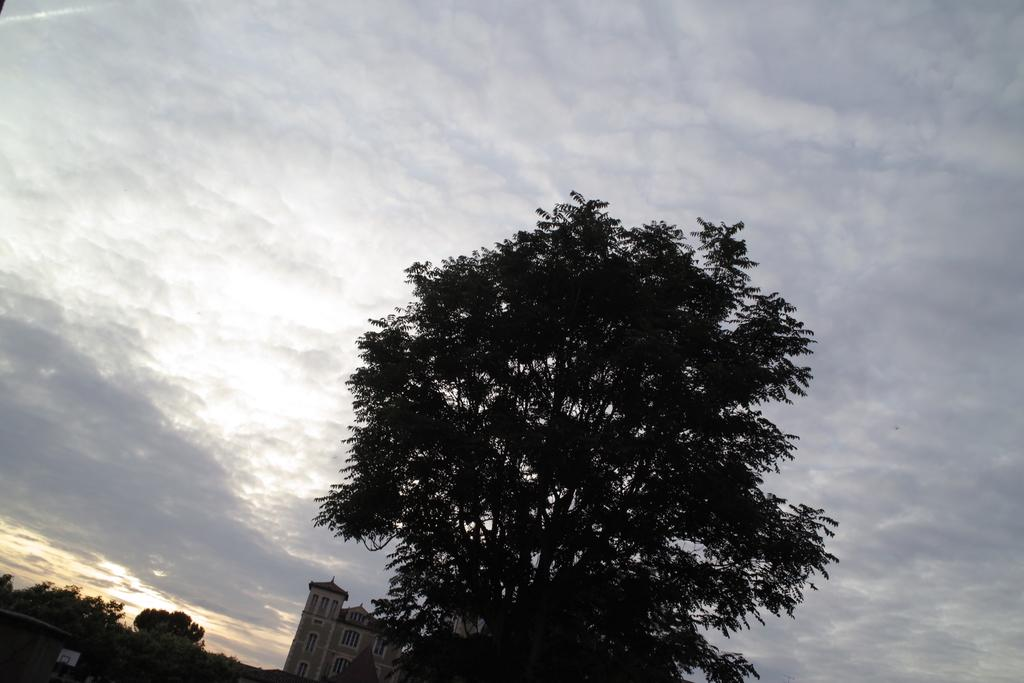What is the main subject in the middle of the picture? There is a tree in the middle of the picture. What other objects or structures can be seen in the left bottom of the picture? There are trees and a building in the left bottom of the picture. What is the color of the building? The building is white in color. What can be seen at the top of the picture? The sky is visible at the top of the picture. Where is the judge standing in the picture? There is no judge present in the picture. What type of hole can be seen in the tree in the picture? There is no hole visible in the tree in the picture. 